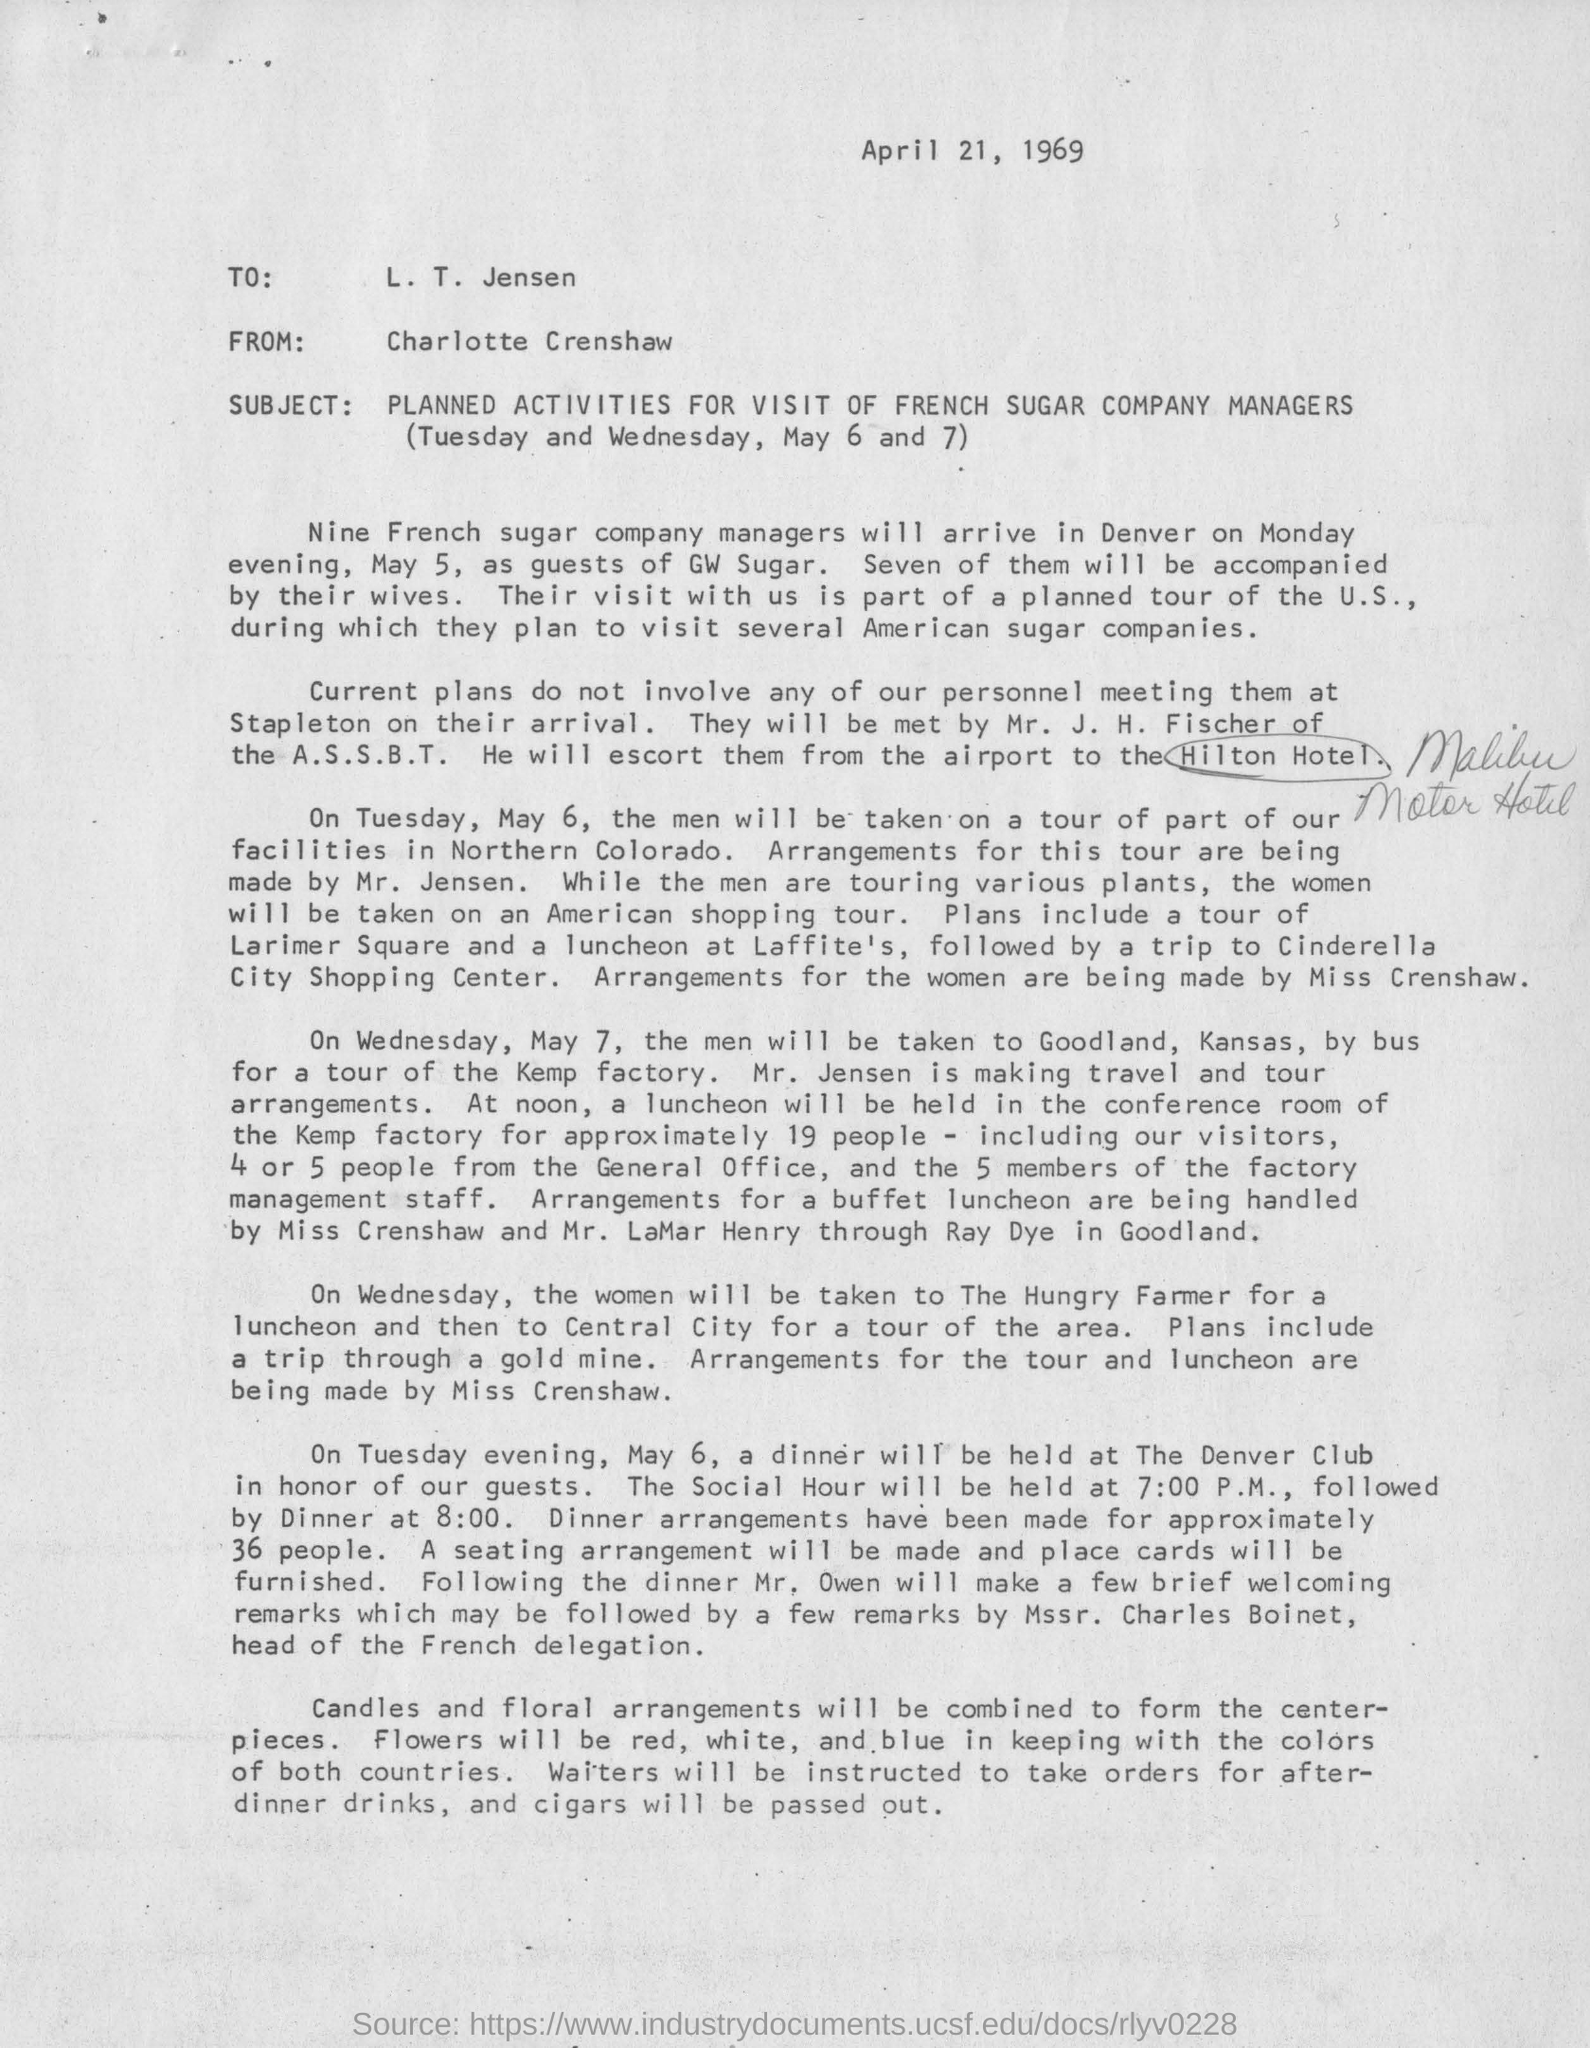Indicate a few pertinent items in this graphic. Seven of them will be accompanied by their wives. The center-pieces will be created by combining candles and floral arrangements. It is expected that cigars will be distributed. The subject of this letter is the planned activities for the visit of French sugar company managers. Nine French sugar company managers will arrive in Denver on Monday evening, May 5. 